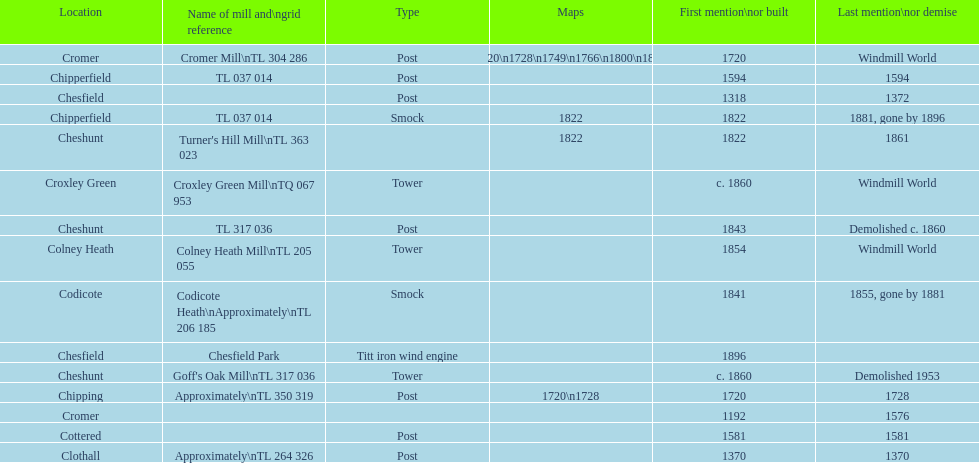How many locations have or had at least 2 windmills? 4. 